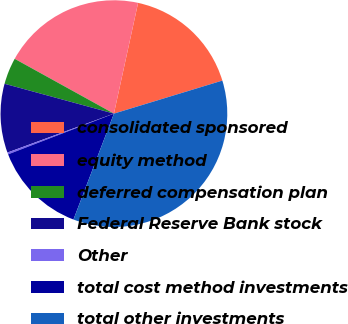Convert chart. <chart><loc_0><loc_0><loc_500><loc_500><pie_chart><fcel>consolidated sponsored<fcel>equity method<fcel>deferred compensation plan<fcel>Federal Reserve Bank stock<fcel>Other<fcel>total cost method investments<fcel>total other investments<nl><fcel>16.87%<fcel>20.39%<fcel>3.79%<fcel>9.82%<fcel>0.27%<fcel>13.34%<fcel>35.51%<nl></chart> 